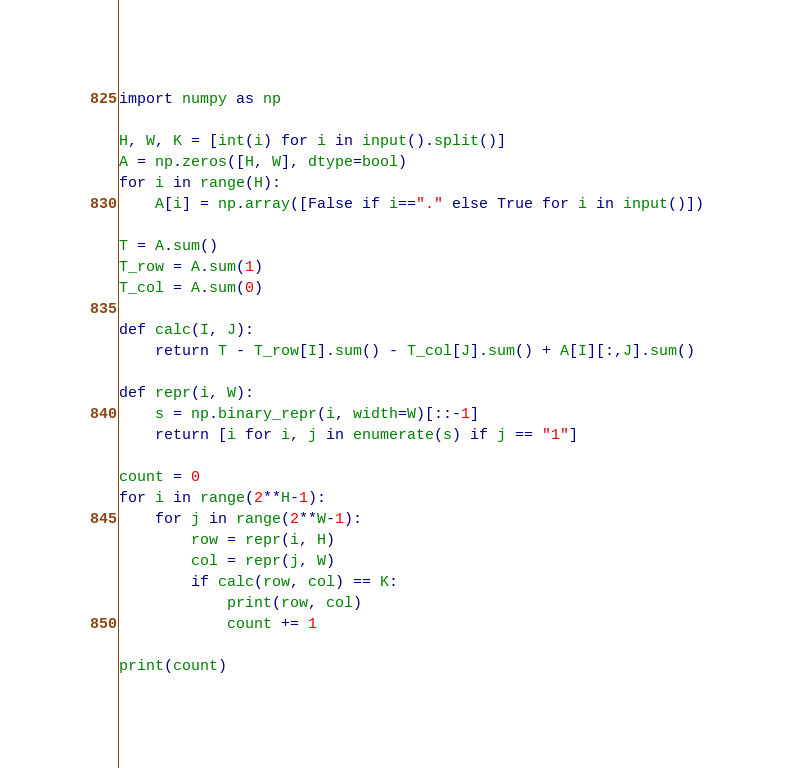Convert code to text. <code><loc_0><loc_0><loc_500><loc_500><_Python_>import numpy as np

H, W, K = [int(i) for i in input().split()]
A = np.zeros([H, W], dtype=bool)
for i in range(H):
    A[i] = np.array([False if i=="." else True for i in input()])

T = A.sum()
T_row = A.sum(1)
T_col = A.sum(0)

def calc(I, J):
    return T - T_row[I].sum() - T_col[J].sum() + A[I][:,J].sum()

def repr(i, W):
    s = np.binary_repr(i, width=W)[::-1]
    return [i for i, j in enumerate(s) if j == "1"]

count = 0
for i in range(2**H-1):
    for j in range(2**W-1):
        row = repr(i, H)
        col = repr(j, W)
        if calc(row, col) == K:
            print(row, col)
            count += 1

print(count)</code> 